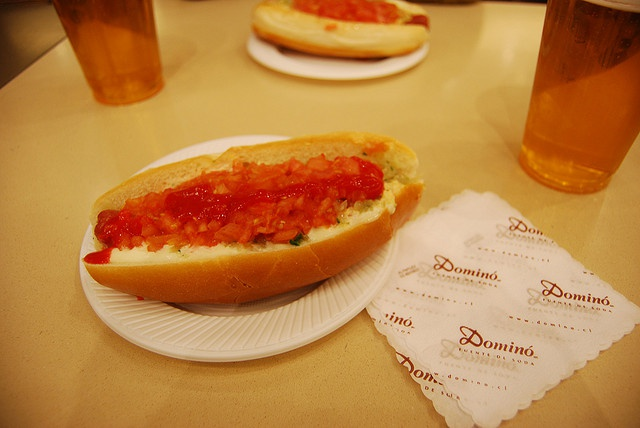Describe the objects in this image and their specific colors. I can see dining table in tan, red, orange, and brown tones, hot dog in black, brown, orange, and red tones, cup in black, brown, maroon, and red tones, cup in black, red, and maroon tones, and hot dog in black, tan, orange, and red tones in this image. 